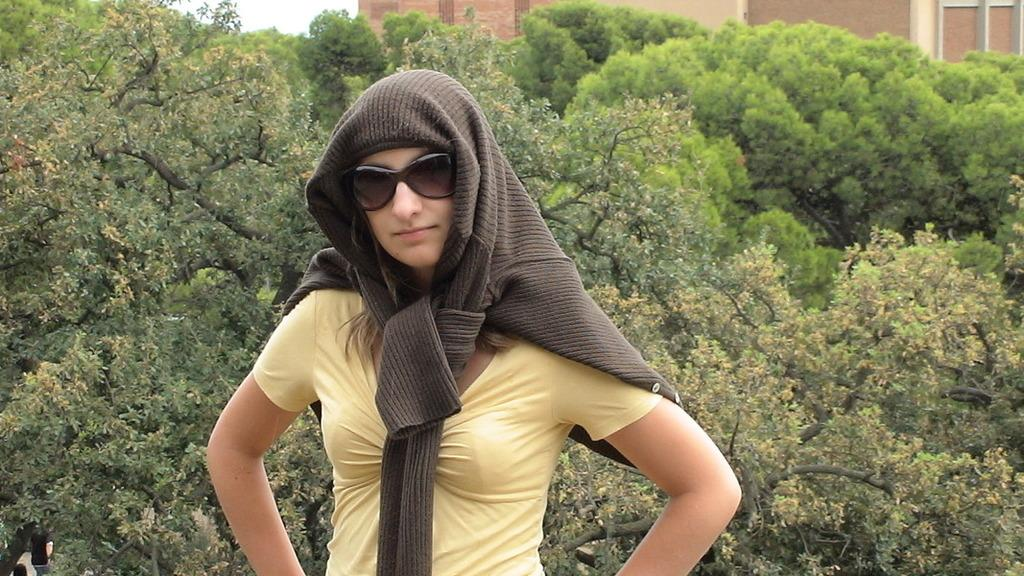Who or what is present in the image? There is a person in the image. What is the person wearing that is noticeable? The person is wearing goggles. What can be seen in the background of the image? There are trees, buildings, and the sky visible in the background of the image. What note is the person singing in the image? There is no indication in the image that the person is singing, so it cannot be determined from the picture. 